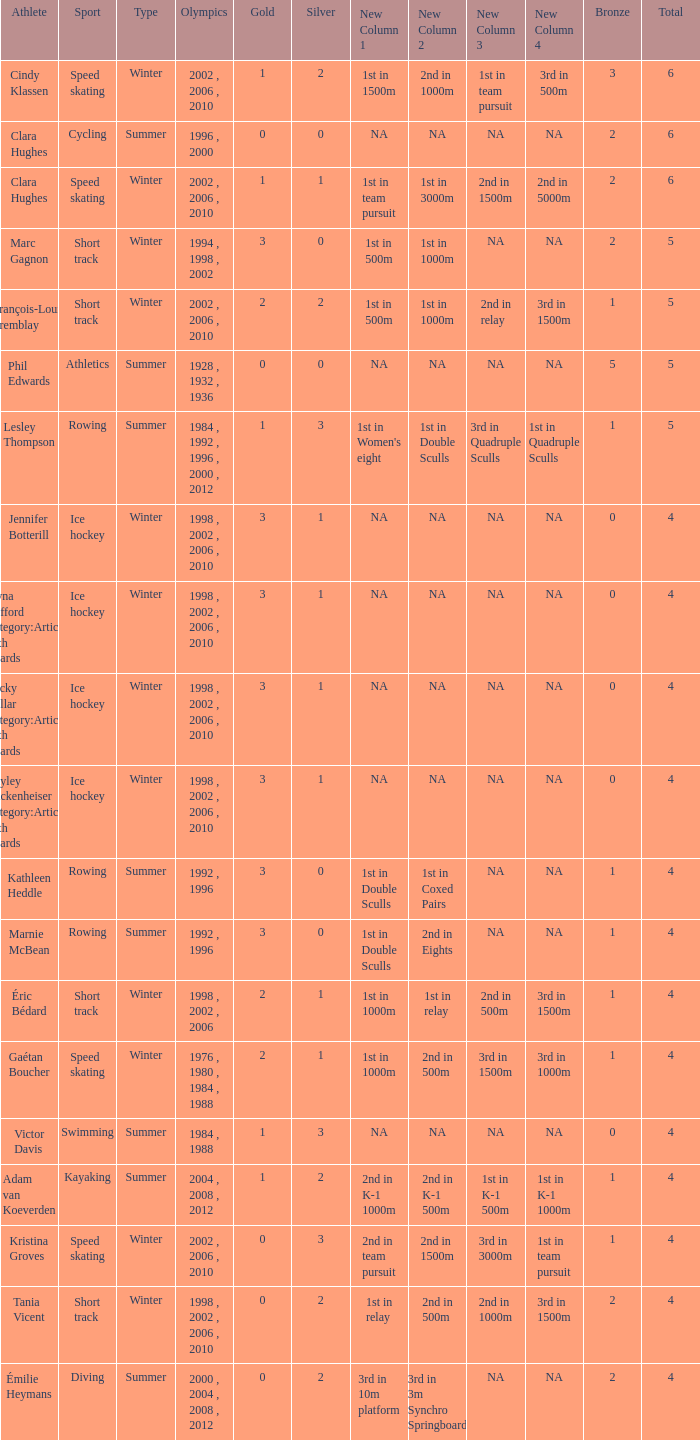What is the average gold of the winter athlete with 1 bronze, less than 3 silver, and less than 4 total medals? None. 